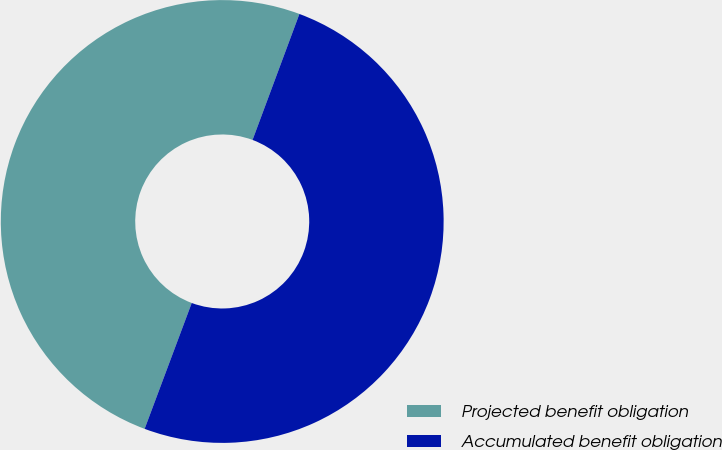Convert chart to OTSL. <chart><loc_0><loc_0><loc_500><loc_500><pie_chart><fcel>Projected benefit obligation<fcel>Accumulated benefit obligation<nl><fcel>49.97%<fcel>50.03%<nl></chart> 